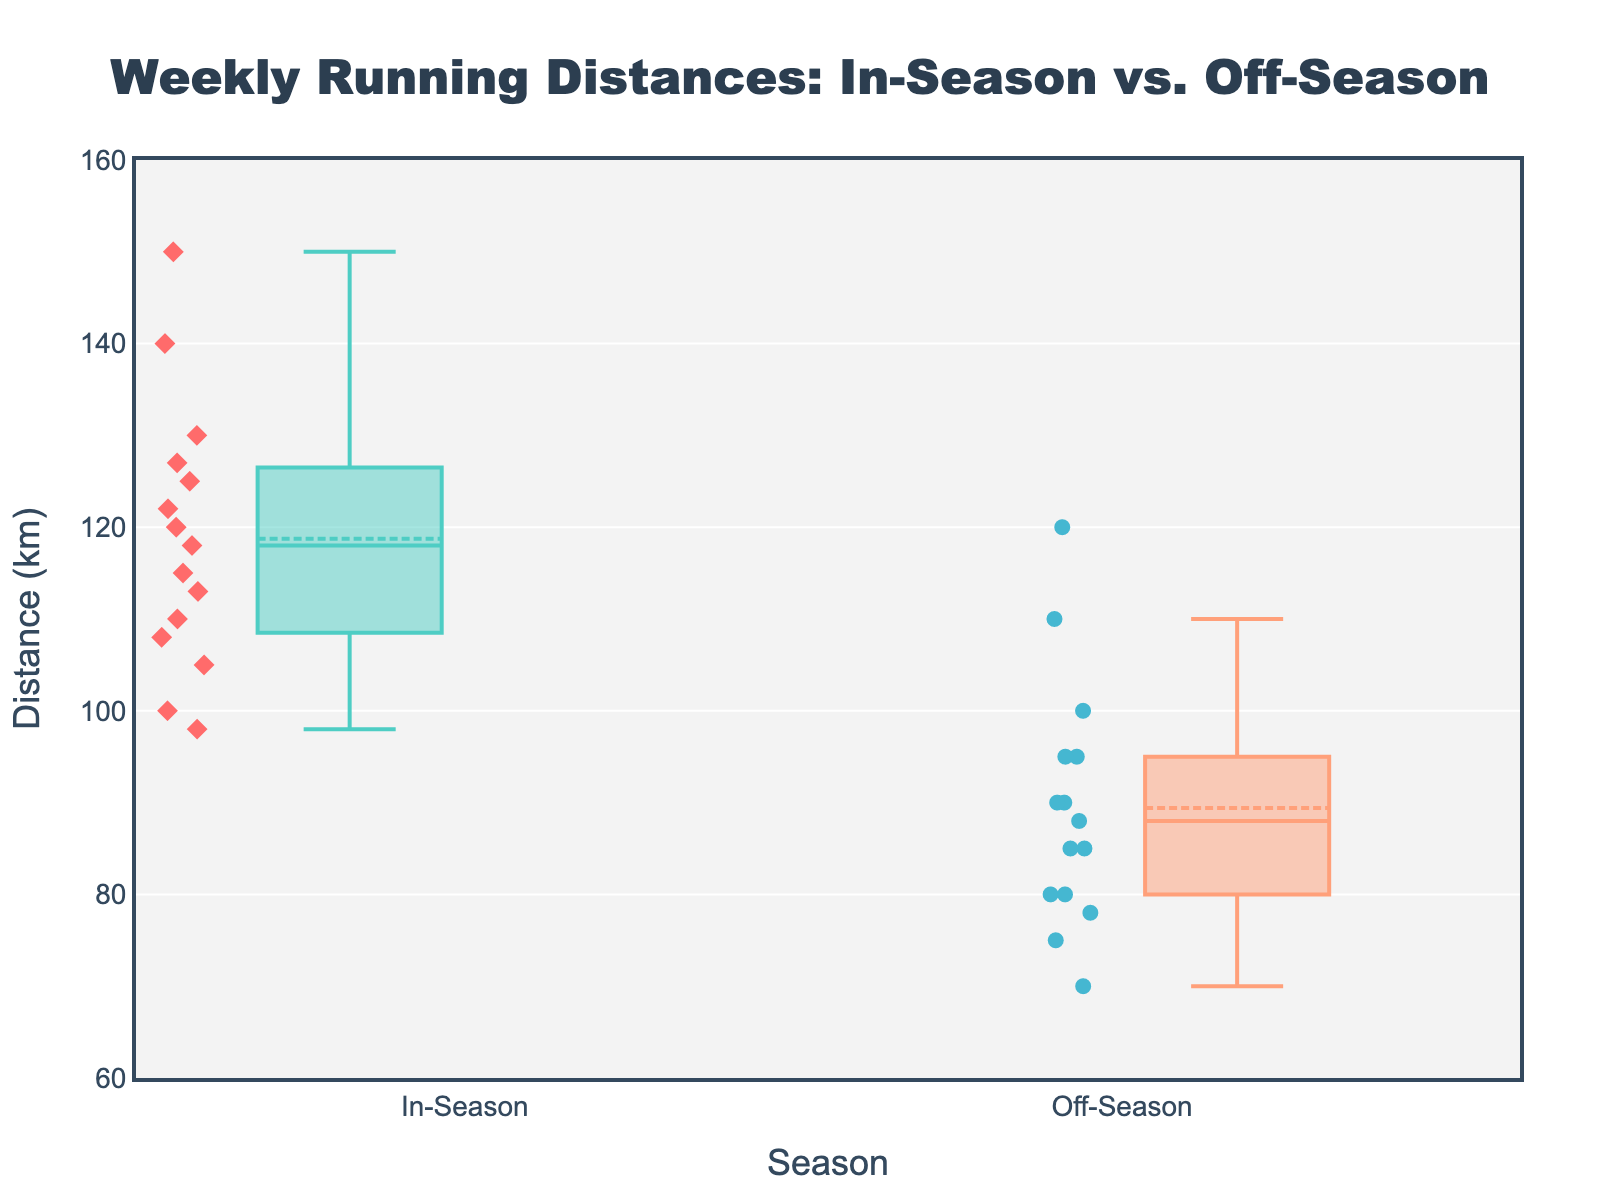What's the title of the plot? The title is displayed at the top center of the plot, clearly denoted in a larger and distinct font.
Answer: Weekly Running Distances: In-Season vs. Off-Season What is the range of distances shown on the y-axis? The range of the y-axis is indicated by the labels on the axis itself. The values start at 60 km and go up to 160 km.
Answer: 60-160 km What colors represent the in-season and off-season data points? The legend, colors of the boxes, or the data points themselves can hint at this. In-season data points are marked in red, and off-season data points are marked in blue.
Answer: Red and blue How many data points are there in each group? By counting the number of individual data points (markers) within each box plot, we can determine there are 15 points in each group.
Answer: 15 What is the median running distance during the in-season? The median is represented by the line within the box of the in-season box plot. From visual inspection, it is around 120 km.
Answer: 120 km What is the mean running distance during the off-season? The mean is indicated by a marker/symbol within each box plot. For the off-season, this marker is placed at around 90 km.
Answer: 90 km Which season has a higher variation in weekly running distances? Variation can be inferred by examining the interquartile range (IQR), which is the height of the box. The in-season box is taller, suggesting a higher variation.
Answer: In-Season What's the interquartile range (IQR) for the in-season group? The IQR is the range between the first quartile (Q1) and the third quartile (Q3). Visual inspection shows the box plot extending from approximately 110 km to 130 km for in-season. The IQR is Q3 - Q1 = 130 - 110.
Answer: 20 km Which season has the highest recorded weekly running distance? This is seen by the furthest outlier or the top whisker of the box plots. The top value for in-season exceeds the off-season, around 150 km for in-season.
Answer: In-Season Are the means of the in-season and off-season groups significantly different? By comparing the position of the mean markers within each box plot (diamond for in-season and circle for off-season), we notice that the in-season mean (around 120 km) is noticeably higher than the off-season mean (around 90 km).
Answer: Yes 